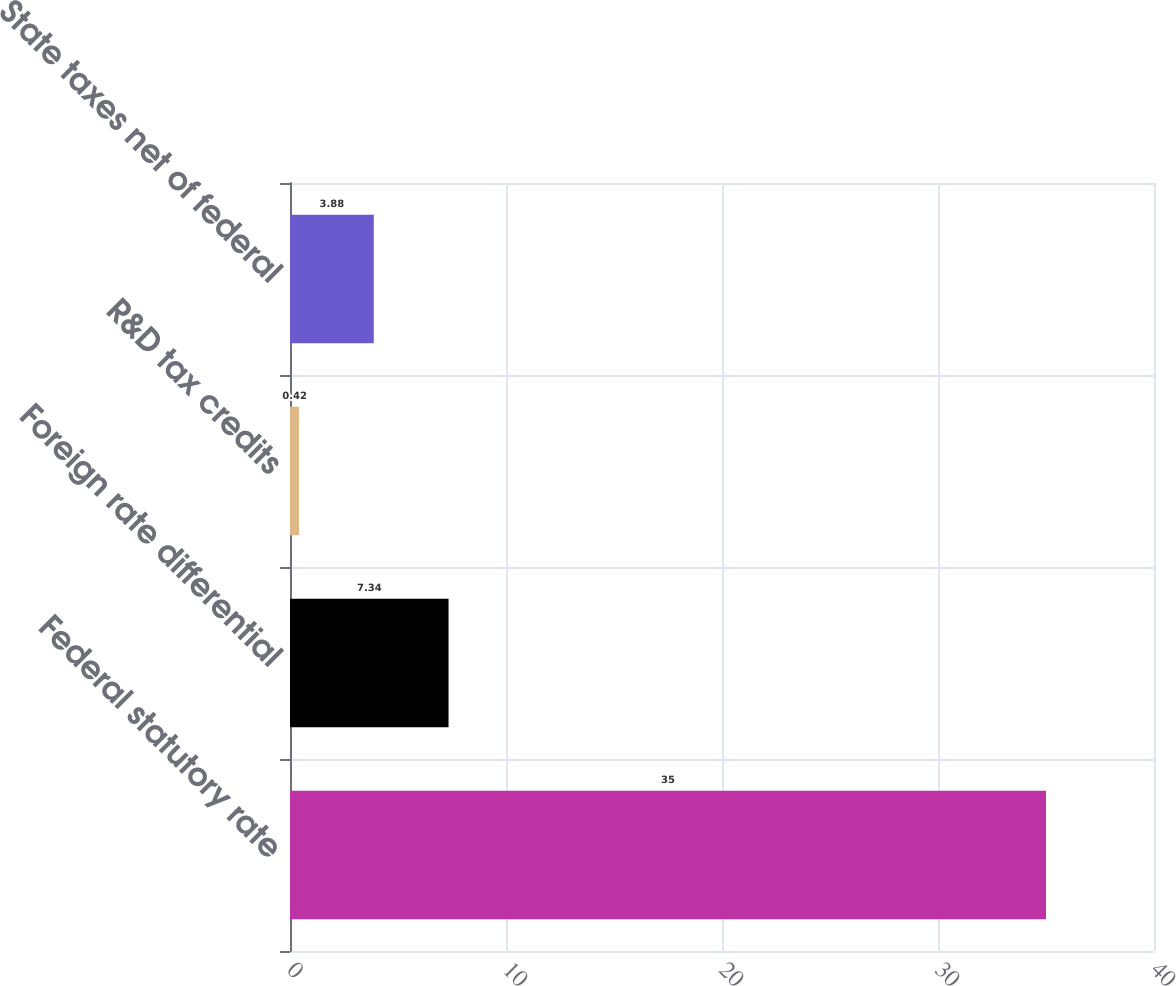Convert chart to OTSL. <chart><loc_0><loc_0><loc_500><loc_500><bar_chart><fcel>Federal statutory rate<fcel>Foreign rate differential<fcel>R&D tax credits<fcel>State taxes net of federal<nl><fcel>35<fcel>7.34<fcel>0.42<fcel>3.88<nl></chart> 